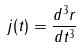Convert formula to latex. <formula><loc_0><loc_0><loc_500><loc_500>j ( t ) = \frac { d ^ { 3 } r } { d t ^ { 3 } }</formula> 